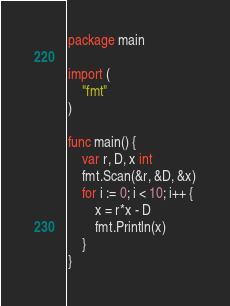<code> <loc_0><loc_0><loc_500><loc_500><_Go_>package main

import (
	"fmt"
)

func main() {
	var r, D, x int
	fmt.Scan(&r, &D, &x)
	for i := 0; i < 10; i++ {
		x = r*x - D
		fmt.Println(x)
	}
}
</code> 